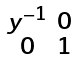Convert formula to latex. <formula><loc_0><loc_0><loc_500><loc_500>\begin{smallmatrix} y ^ { - 1 } & 0 \\ 0 & 1 \\ \end{smallmatrix}</formula> 